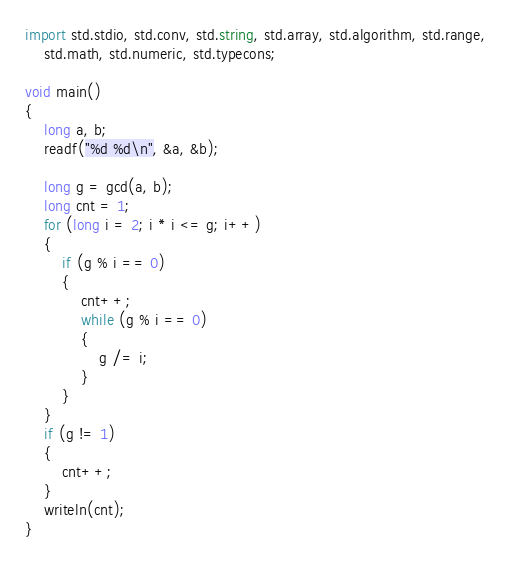<code> <loc_0><loc_0><loc_500><loc_500><_D_>import std.stdio, std.conv, std.string, std.array, std.algorithm, std.range,
    std.math, std.numeric, std.typecons;

void main()
{
    long a, b;
    readf("%d %d\n", &a, &b);

    long g = gcd(a, b);
    long cnt = 1;
    for (long i = 2; i * i <= g; i++)
    {
        if (g % i == 0)
        {
            cnt++;
            while (g % i == 0)
            {
                g /= i;
            }
        }
    }
    if (g != 1)
    {
        cnt++;
    }
    writeln(cnt);
}
</code> 